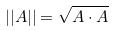<formula> <loc_0><loc_0><loc_500><loc_500>| | A | | = \sqrt { A \cdot A }</formula> 